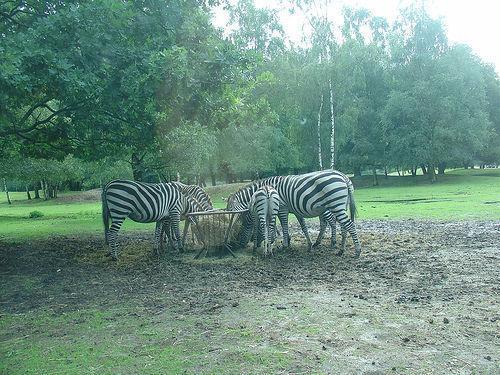How many zebras are there?
Give a very brief answer. 4. How many zebras are there?
Give a very brief answer. 2. 